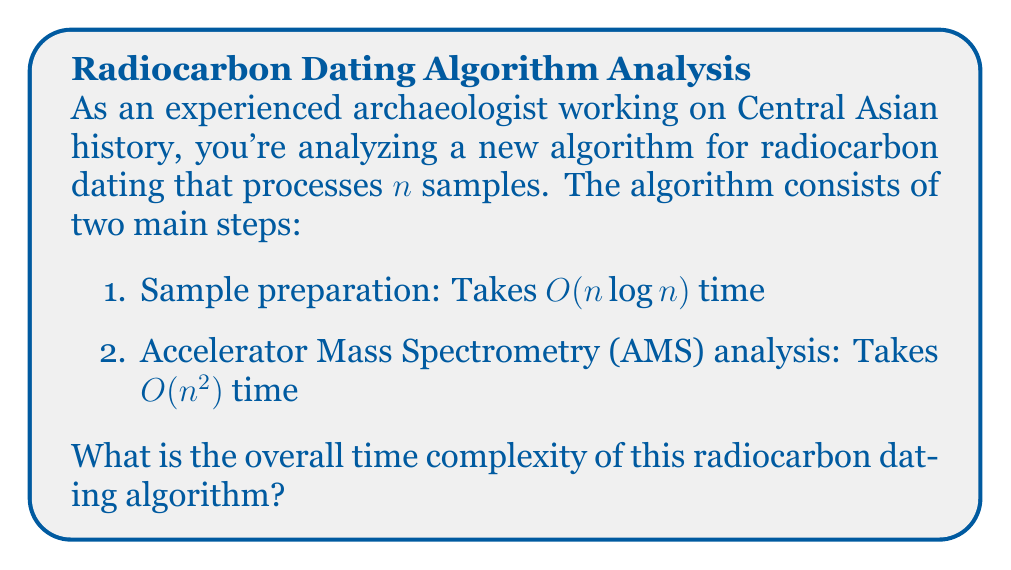What is the answer to this math problem? To determine the overall time complexity of the algorithm, we need to follow these steps:

1. Identify the time complexities of each step:
   - Sample preparation: $O(n \log n)$
   - AMS analysis: $O(n^2)$

2. Combine the time complexities:
   The total time is the sum of the time taken by each step.
   Total time = $O(n \log n) + O(n^2)$

3. Simplify using the properties of Big O notation:
   When adding time complexities, we keep the dominant (slower-growing) term.
   
   Compare the growth rates:
   - $n \log n$ grows more slowly than $n^2$ for large $n$
   - $n^2$ is the dominant term

4. Therefore, we can simplify the total time to:
   Total time = $O(n^2)$

The AMS analysis step, with its quadratic time complexity, dominates the overall running time of the algorithm, making the sample preparation step's contribution negligible for large $n$.
Answer: $O(n^2)$ 